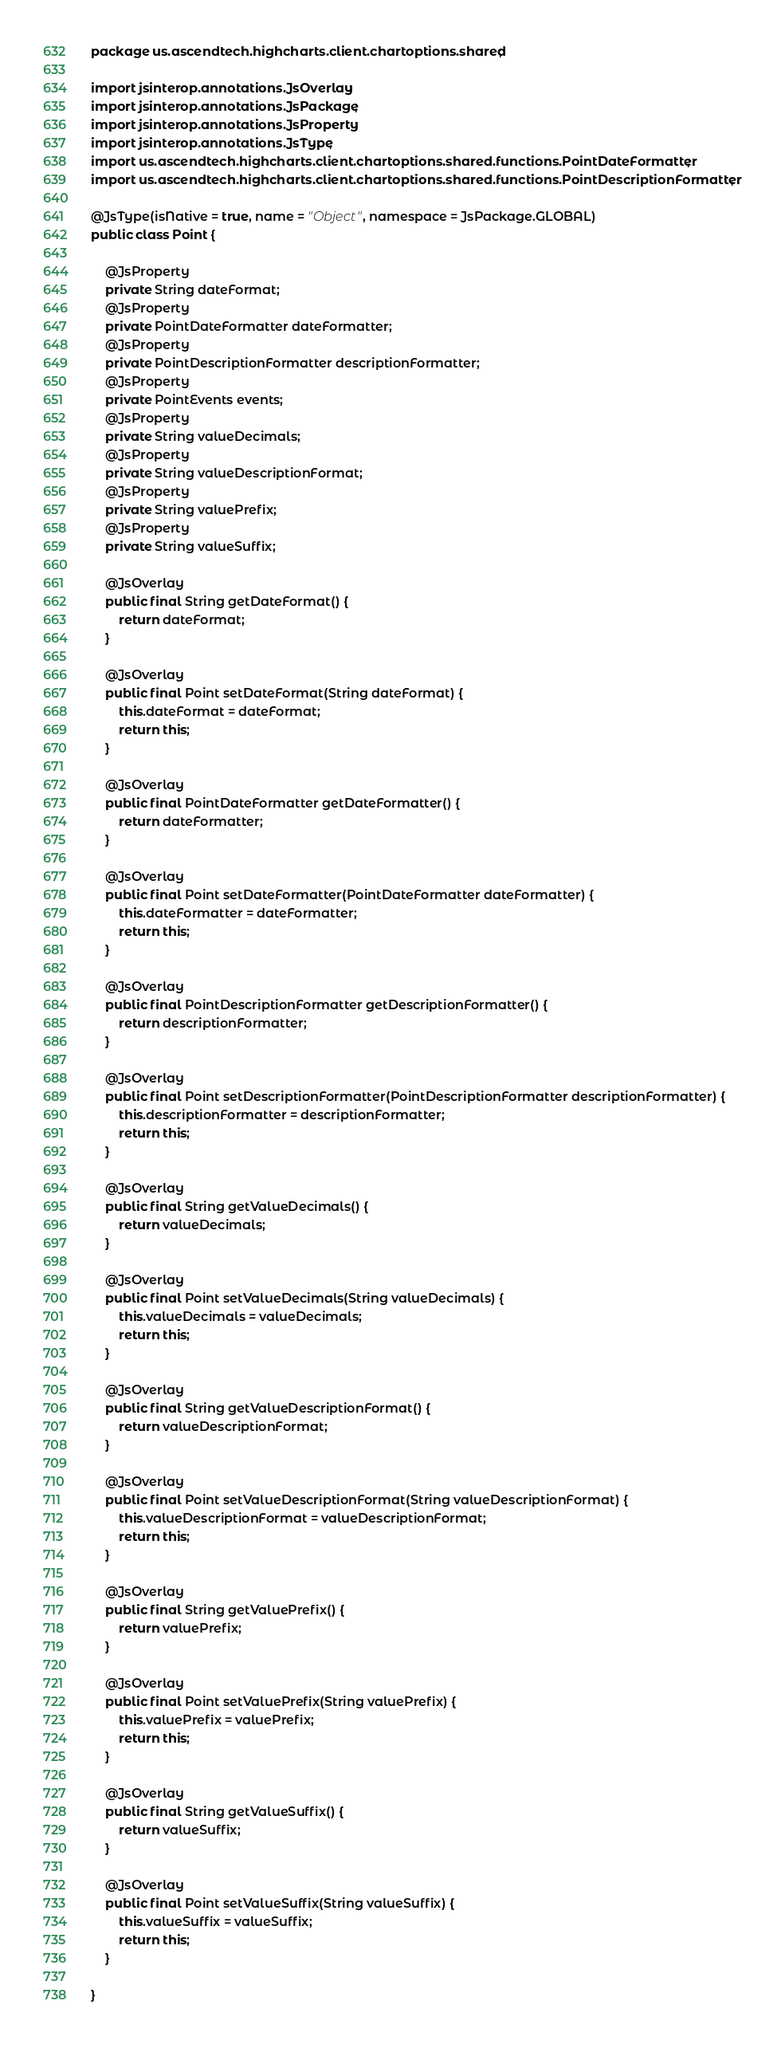Convert code to text. <code><loc_0><loc_0><loc_500><loc_500><_Java_>package us.ascendtech.highcharts.client.chartoptions.shared;

import jsinterop.annotations.JsOverlay;
import jsinterop.annotations.JsPackage;
import jsinterop.annotations.JsProperty;
import jsinterop.annotations.JsType;
import us.ascendtech.highcharts.client.chartoptions.shared.functions.PointDateFormatter;
import us.ascendtech.highcharts.client.chartoptions.shared.functions.PointDescriptionFormatter;

@JsType(isNative = true, name = "Object", namespace = JsPackage.GLOBAL)
public class Point {

	@JsProperty
	private String dateFormat;
	@JsProperty
	private PointDateFormatter dateFormatter;
	@JsProperty
	private PointDescriptionFormatter descriptionFormatter;
	@JsProperty
	private PointEvents events;
	@JsProperty
	private String valueDecimals;
	@JsProperty
	private String valueDescriptionFormat;
	@JsProperty
	private String valuePrefix;
	@JsProperty
	private String valueSuffix;

	@JsOverlay
	public final String getDateFormat() {
		return dateFormat;
	}

	@JsOverlay
	public final Point setDateFormat(String dateFormat) {
		this.dateFormat = dateFormat;
		return this;
	}

	@JsOverlay
	public final PointDateFormatter getDateFormatter() {
		return dateFormatter;
	}

	@JsOverlay
	public final Point setDateFormatter(PointDateFormatter dateFormatter) {
		this.dateFormatter = dateFormatter;
		return this;
	}

	@JsOverlay
	public final PointDescriptionFormatter getDescriptionFormatter() {
		return descriptionFormatter;
	}

	@JsOverlay
	public final Point setDescriptionFormatter(PointDescriptionFormatter descriptionFormatter) {
		this.descriptionFormatter = descriptionFormatter;
		return this;
	}

	@JsOverlay
	public final String getValueDecimals() {
		return valueDecimals;
	}

	@JsOverlay
	public final Point setValueDecimals(String valueDecimals) {
		this.valueDecimals = valueDecimals;
		return this;
	}

	@JsOverlay
	public final String getValueDescriptionFormat() {
		return valueDescriptionFormat;
	}

	@JsOverlay
	public final Point setValueDescriptionFormat(String valueDescriptionFormat) {
		this.valueDescriptionFormat = valueDescriptionFormat;
		return this;
	}

	@JsOverlay
	public final String getValuePrefix() {
		return valuePrefix;
	}

	@JsOverlay
	public final Point setValuePrefix(String valuePrefix) {
		this.valuePrefix = valuePrefix;
		return this;
	}

	@JsOverlay
	public final String getValueSuffix() {
		return valueSuffix;
	}

	@JsOverlay
	public final Point setValueSuffix(String valueSuffix) {
		this.valueSuffix = valueSuffix;
		return this;
	}

}
</code> 